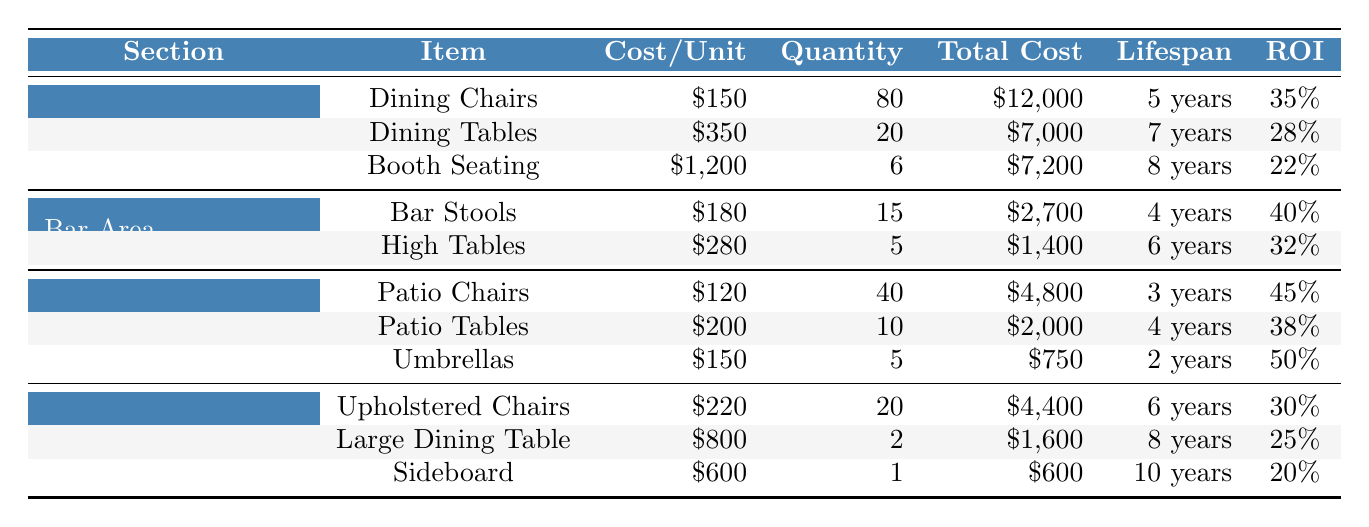What is the total cost of furniture in the Main Dining Area? To find the total cost in the Main Dining Area, sum the total costs of Dining Chairs, Dining Tables, and Booth Seating. Total Cost = \$12,000 + \$7,000 + \$7,200 = \$26,200.
Answer: \$26,200 What is the expected lifespan of the Patio Tables? The expected lifespan of Patio Tables is stated directly in the table as 4 years.
Answer: 4 years Which furniture item in the Bar Area has the highest ROI? The Bar Stools have an Annual ROI of 40%, which is higher than the High Tables at 32%.
Answer: Bar Stools What is the average cost per unit of furniture in the Private Dining Room? To find the average cost per unit, sum the costs of Upholstered Chairs, Large Dining Table, and Sideboard: \$220 + \$800 + \$600 = \$1,620. Then, divide by the number of items (3): \$1,620 / 3 = \$540.
Answer: \$540 Which section has the highest total furniture cost? Total furniture costs for Main Dining Area (\$26,200), Bar Area (\$4,100), Outdoor Patio (\$7,550), and Private Dining Room (\$6,600). The Main Dining Area has the highest cost: \$26,200.
Answer: Main Dining Area Does the Umbrellas have a shorter expected lifespan than the Patio Chairs? The Umbrellas have an expected lifespan of 2 years while Patio Chairs have 3 years. So, yes, Umbrellas have a shorter lifespan.
Answer: Yes What is the total ROI for furniture in the Outdoor Patio section? Identify the annual ROI for each item: 45% (Patio Chairs), 38% (Patio Tables), 50% (Umbrellas). Since there is no straightforward method to sum these, we can consider these values as separate returns without a direct cumulative value. However, on average, the annual ROI can be calculated as (45% + 38% + 50%) / 3 = 44.33%.
Answer: 44.33% How many furniture items in total are there in the Bar Area? The Bar Area contains 2 items: Bar Stools and High Tables (total: 1 + 1 = 2 items).
Answer: 2 items Which section has furniture with the highest individual item cost? Compare individual item costs: Dining Chairs (\$150), Dining Tables (\$350), Booth Seating (\$1,200), Bar Stools (\$180), High Tables (\$280), Patio Chairs (\$120), Patio Tables (\$200), Umbrellas (\$150), Upholstered Chairs (\$220), Large Dining Table (\$800), and Sideboard (\$600). Booth Seating at \$1,200 is the highest.
Answer: Main Dining Area (Booth Seating) What is the relationship between the total cost and expected lifespan for Dining Tables in the Main Dining Area? The total cost of Dining Tables is \$7,000 with an expected lifespan of 7 years. The relationship can be assessed in terms of cost per year, which is \$7,000 / 7 = \$1,000 per year. This indicates that for each year, the cost of keeping a Dining Table is \$1,000.
Answer: \$1,000 per year 